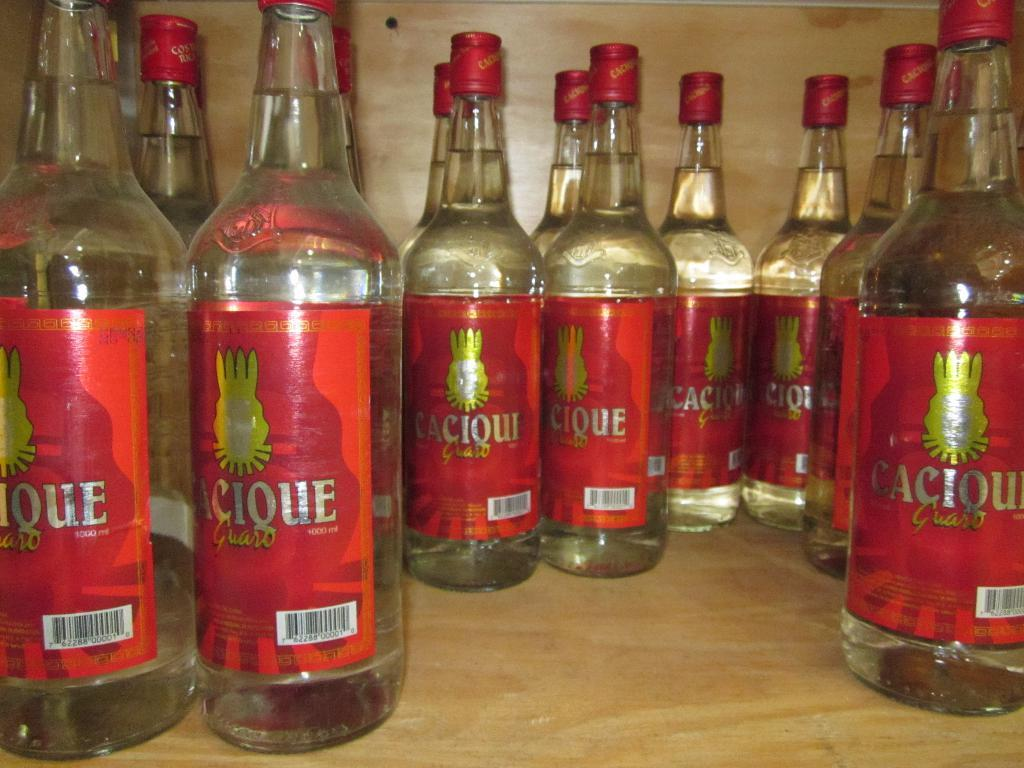<image>
Write a terse but informative summary of the picture. A bunch of bottles called Caciquo sit on a shelf. 